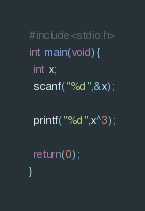<code> <loc_0><loc_0><loc_500><loc_500><_C_>#include<stdio.h>
int main(void){
 int x;
 scanf("%d",&x);

 printf("%d",x^3);

 return(0);
} </code> 